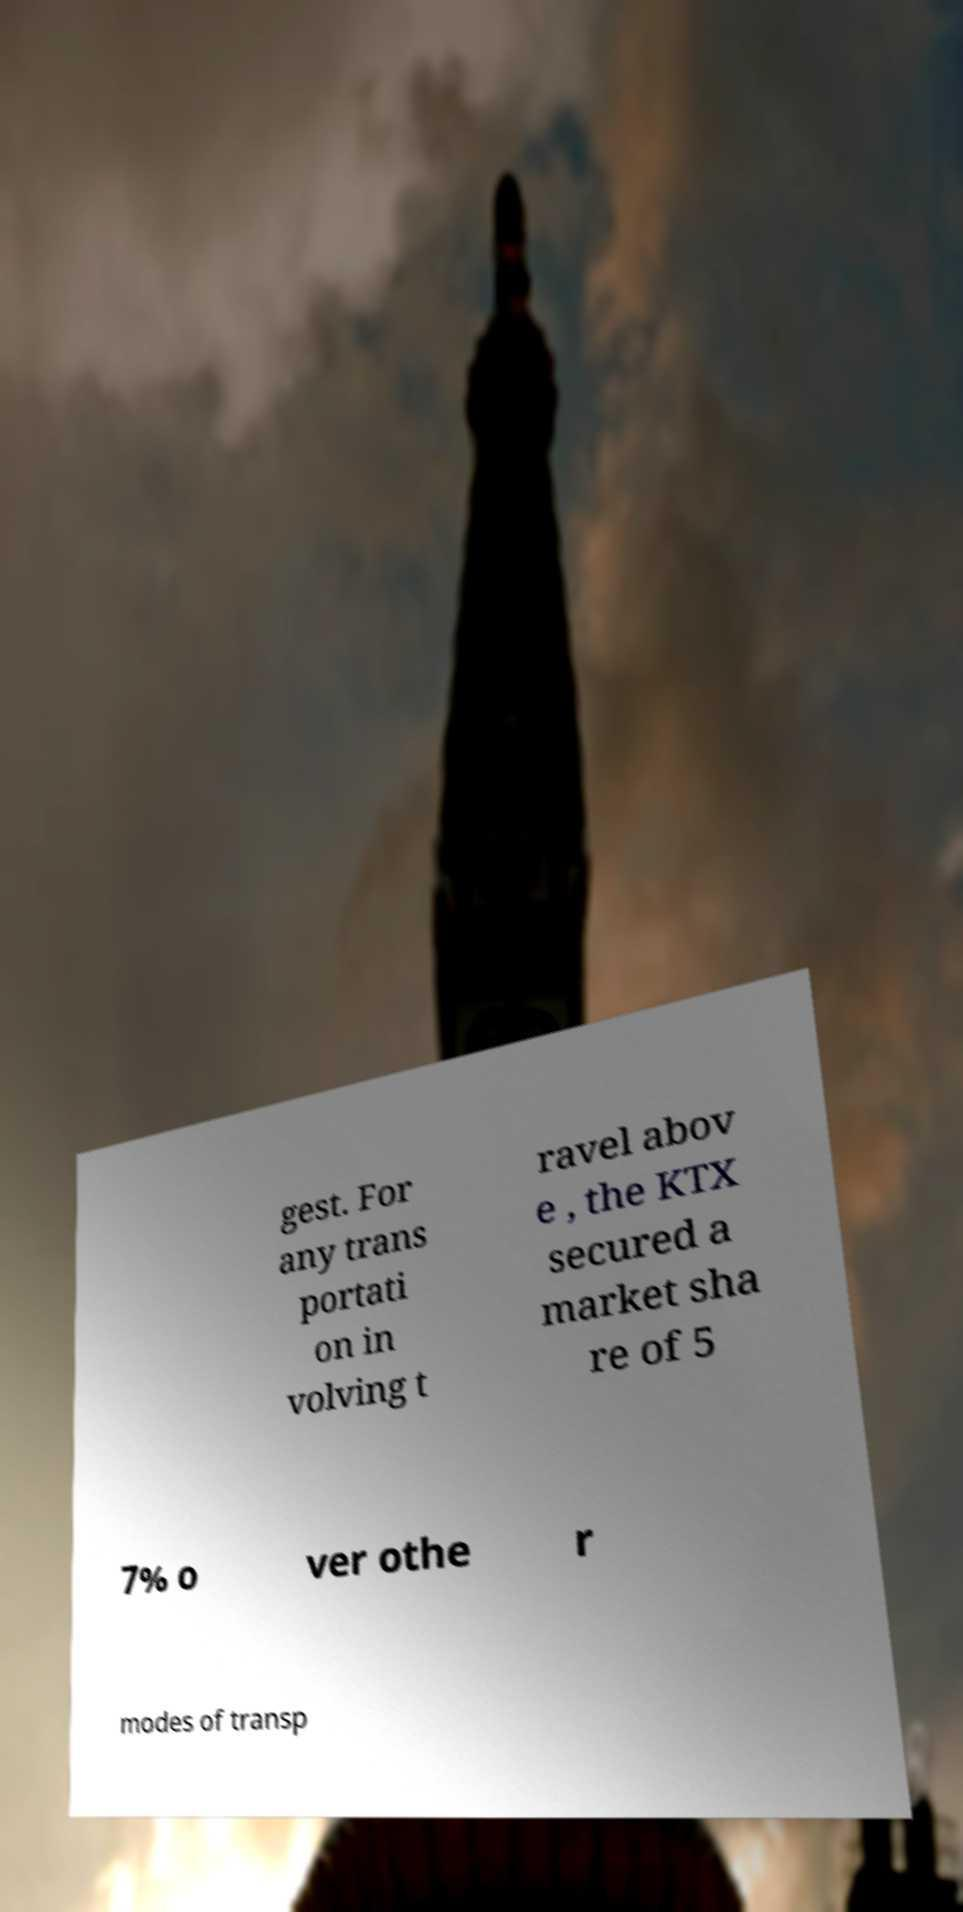Please identify and transcribe the text found in this image. gest. For any trans portati on in volving t ravel abov e , the KTX secured a market sha re of 5 7% o ver othe r modes of transp 